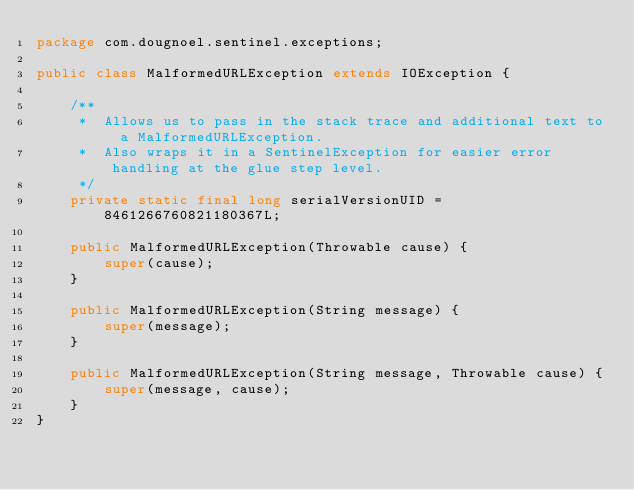Convert code to text. <code><loc_0><loc_0><loc_500><loc_500><_Java_>package com.dougnoel.sentinel.exceptions;

public class MalformedURLException extends IOException {

    /**
     *  Allows us to pass in the stack trace and additional text to a MalformedURLException.
     *  Also wraps it in a SentinelException for easier error handling at the glue step level.
     */
    private static final long serialVersionUID = 8461266760821180367L;

    public MalformedURLException(Throwable cause) {
        super(cause);
    }
    
    public MalformedURLException(String message) {
        super(message);
    }

    public MalformedURLException(String message, Throwable cause) {
        super(message, cause);
    }
}
</code> 